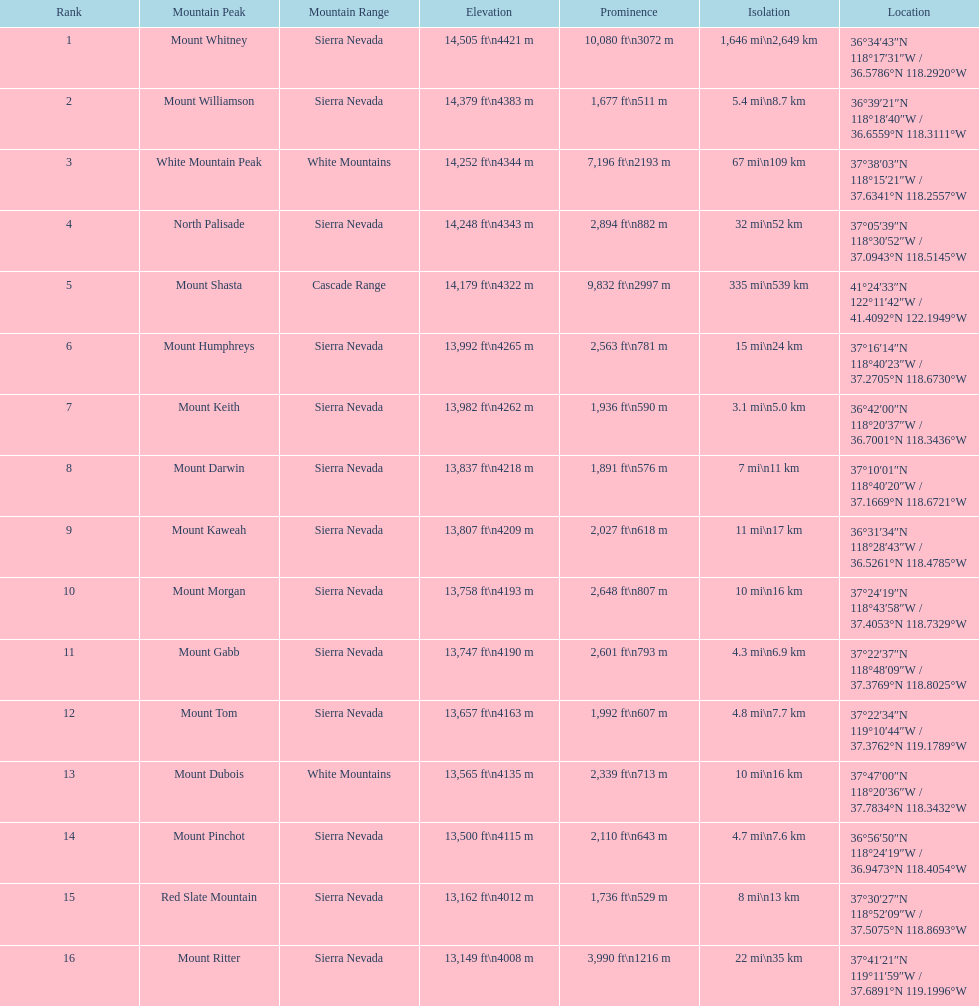Which mountain summit boasts a prominence exceeding 10,000 feet? Mount Whitney. 